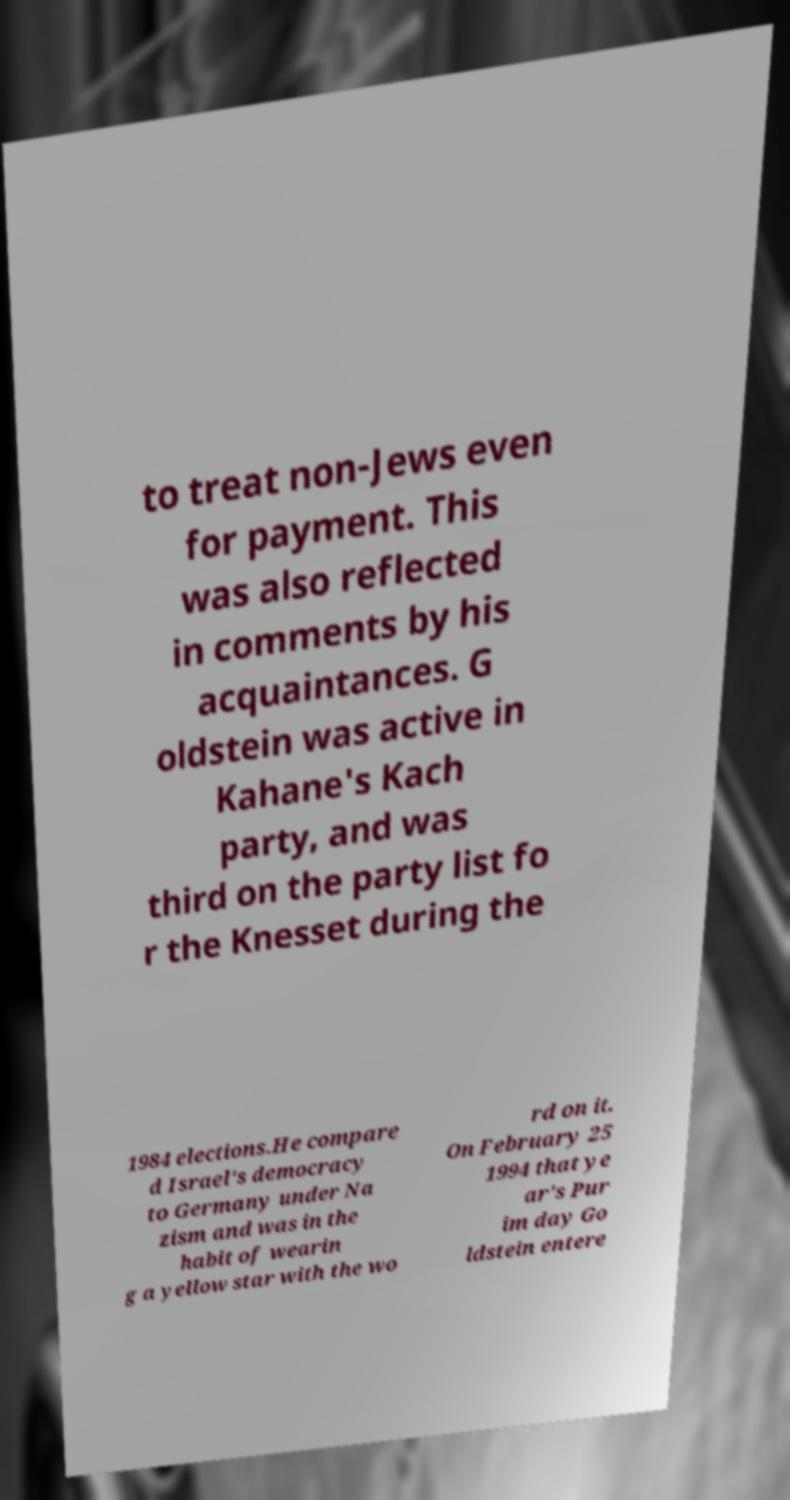Could you extract and type out the text from this image? to treat non-Jews even for payment. This was also reflected in comments by his acquaintances. G oldstein was active in Kahane's Kach party, and was third on the party list fo r the Knesset during the 1984 elections.He compare d Israel's democracy to Germany under Na zism and was in the habit of wearin g a yellow star with the wo rd on it. On February 25 1994 that ye ar's Pur im day Go ldstein entere 